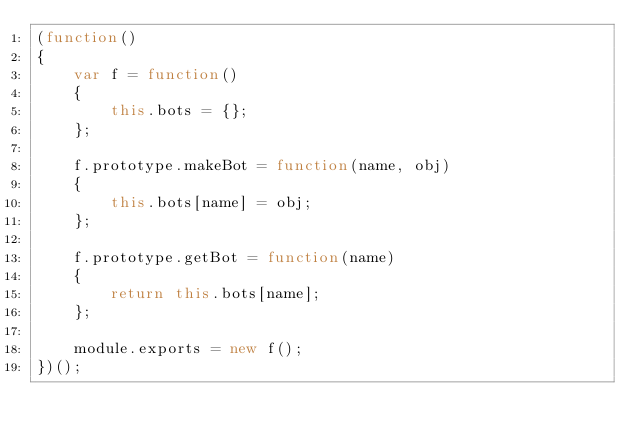Convert code to text. <code><loc_0><loc_0><loc_500><loc_500><_JavaScript_>(function()
{
    var f = function()
    {
        this.bots = {};
    };

    f.prototype.makeBot = function(name, obj)
    {
        this.bots[name] = obj;
    };

    f.prototype.getBot = function(name)
    {
        return this.bots[name];
    };

    module.exports = new f();
})();
</code> 